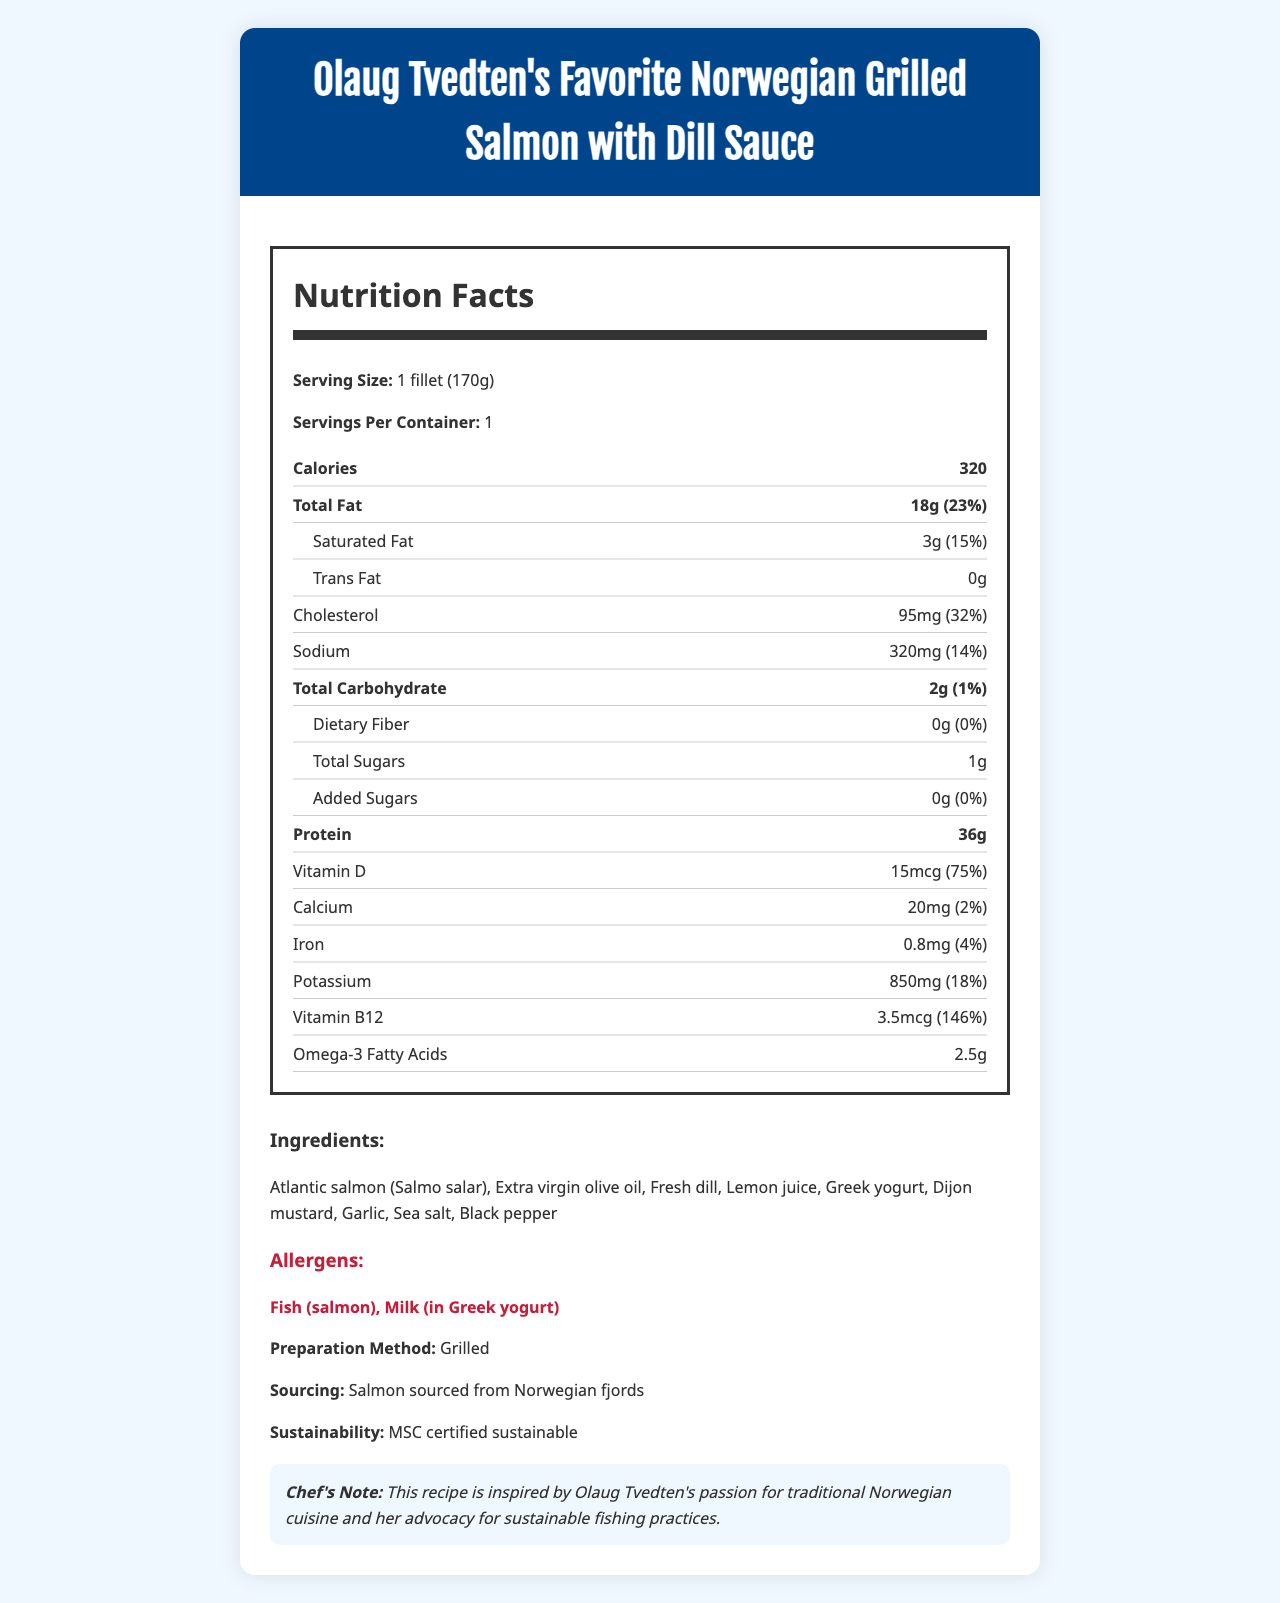what is the serving size for the dish? The serving size is listed as "1 fillet (170g)" under the Nutrition Facts section.
Answer: 1 fillet (170g) how many calories are in one serving of the dish? Under the Nutrition Facts, the calories per serving are listed as 320.
Answer: 320 what percentage of the daily value for total fat does one serving contain? The Total Fat amount and its daily value percentage are listed: 18g (23%).
Answer: 23% what is the daily value percentage of Vitamin D in this dish? The daily value for Vitamin D is mentioned as 75% in the Nutrition Facts section.
Answer: 75% which ingredient contains an allergen? The allergens listed include Fish (salmon) and Milk (in Greek yogurt).
Answer: Greek yogurt how much protein does one serving of the salmon dish provide? The amount of protein per serving is listed as 36g in the Nutrition Facts section.
Answer: 36g how much cholesterol is in one serving of the dish? The cholesterol content is listed as 95mg.
Answer: 95mg what is the preparation method for the dish? The preparation method is stated as "Grilled" in the document.
Answer: Grilled how much omega-3 fatty acids does one serving contain? The document lists the omega-3 fatty acids content as 2.5g.
Answer: 2.5g what is the sodium content in one serving? A. 100mg B. 320mg C. 400mg D. 500mg The sodium content for one serving is listed as 320mg in the Nutrition Facts section.
Answer: B. 320mg how much calcium is in one serving of the dish? A. 10mg B. 20mg C. 50mg D. 100mg The calcium content per serving is listed as 20mg.
Answer: B. 20mg is there any added sugar in the dish? The document states that the amount of added sugars is 0g.
Answer: No does the dish include any fiber? The dietary fiber amount is listed as 0g in the Nutrition Facts section.
Answer: No describe the main idea of the document. The document comprehensively details the nutritional content, ingredients, allergen information, and additional notes on sourcing and preparation of Olaug Tvedten's favorite dish.
Answer: The document provides detailed nutrition information for "Olaug Tvedten's Favorite Norwegian Grilled Salmon with Dill Sauce," including serving size, calories, macronutrient and micronutrient content, ingredients, allergens, preparation method, sourcing, sustainability, and a chef’s note. what is Olaug Tvedten's favorite sport? The document focuses solely on the nutrition details of the salmon dish, without mentioning any personal interests like sports.
Answer: Not enough information what is the protein source in the dish? The primary protein source is Atlantic salmon, which is listed among the ingredients.
Answer: Atlantic salmon (Salmo salar) 